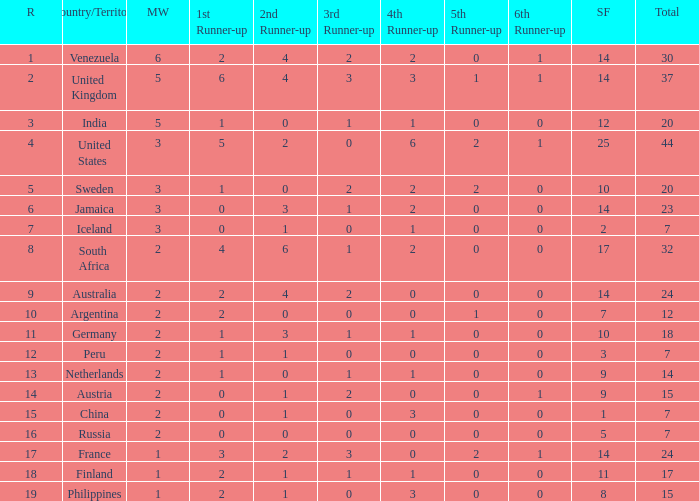What is the united states' rating? 1.0. 